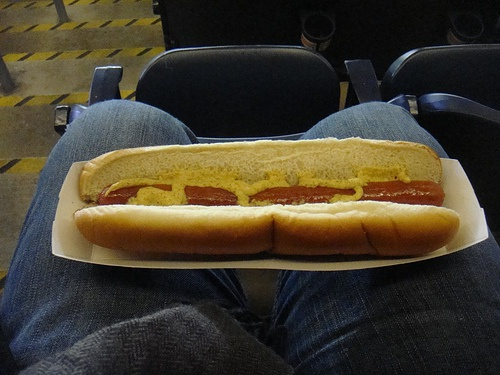Describe the objects in this image and their specific colors. I can see hot dog in black, maroon, olive, and tan tones, chair in black, gray, and darkgreen tones, bowl in black, tan, and olive tones, chair in black, gray, navy, and darkblue tones, and chair in black, gray, navy, and darkgray tones in this image. 